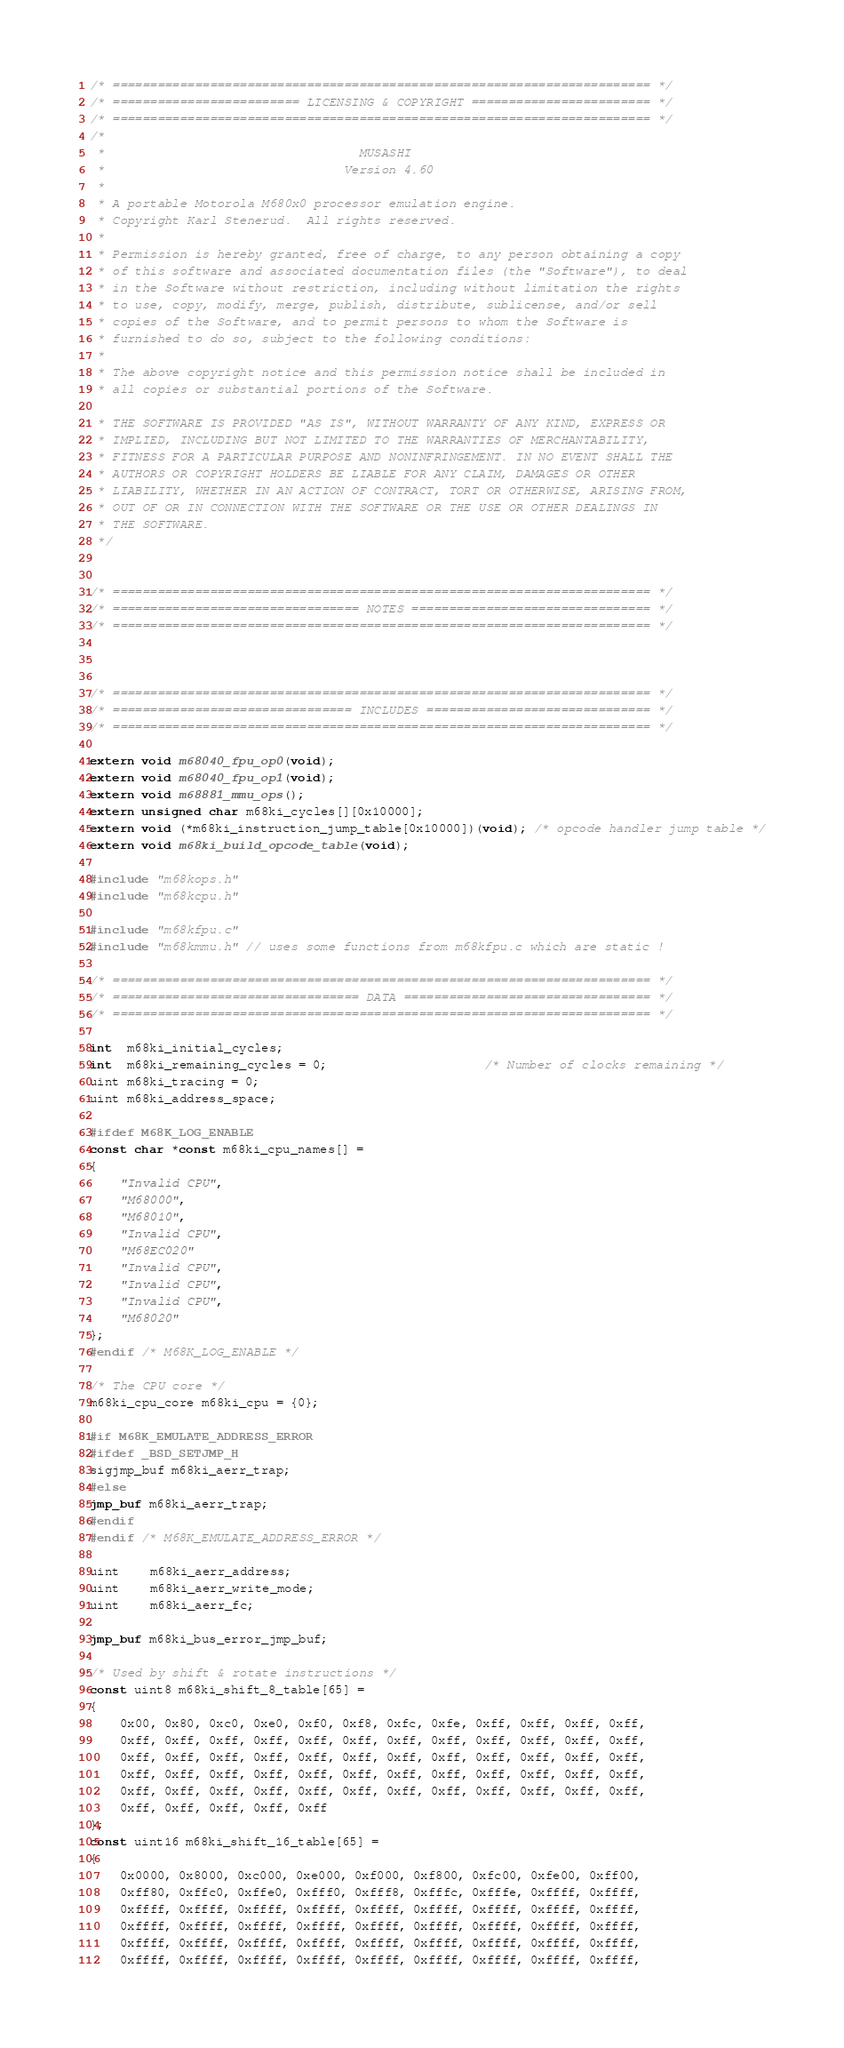Convert code to text. <code><loc_0><loc_0><loc_500><loc_500><_C_>/* ======================================================================== */
/* ========================= LICENSING & COPYRIGHT ======================== */
/* ======================================================================== */
/*
 *                                  MUSASHI
 *                                Version 4.60
 *
 * A portable Motorola M680x0 processor emulation engine.
 * Copyright Karl Stenerud.  All rights reserved.
 *
 * Permission is hereby granted, free of charge, to any person obtaining a copy
 * of this software and associated documentation files (the "Software"), to deal
 * in the Software without restriction, including without limitation the rights
 * to use, copy, modify, merge, publish, distribute, sublicense, and/or sell
 * copies of the Software, and to permit persons to whom the Software is
 * furnished to do so, subject to the following conditions:
 *
 * The above copyright notice and this permission notice shall be included in
 * all copies or substantial portions of the Software.

 * THE SOFTWARE IS PROVIDED "AS IS", WITHOUT WARRANTY OF ANY KIND, EXPRESS OR
 * IMPLIED, INCLUDING BUT NOT LIMITED TO THE WARRANTIES OF MERCHANTABILITY,
 * FITNESS FOR A PARTICULAR PURPOSE AND NONINFRINGEMENT. IN NO EVENT SHALL THE
 * AUTHORS OR COPYRIGHT HOLDERS BE LIABLE FOR ANY CLAIM, DAMAGES OR OTHER
 * LIABILITY, WHETHER IN AN ACTION OF CONTRACT, TORT OR OTHERWISE, ARISING FROM,
 * OUT OF OR IN CONNECTION WITH THE SOFTWARE OR THE USE OR OTHER DEALINGS IN
 * THE SOFTWARE.
 */


/* ======================================================================== */
/* ================================= NOTES ================================ */
/* ======================================================================== */



/* ======================================================================== */
/* ================================ INCLUDES ============================== */
/* ======================================================================== */

extern void m68040_fpu_op0(void);
extern void m68040_fpu_op1(void);
extern void m68881_mmu_ops();
extern unsigned char m68ki_cycles[][0x10000];
extern void (*m68ki_instruction_jump_table[0x10000])(void); /* opcode handler jump table */
extern void m68ki_build_opcode_table(void);

#include "m68kops.h"
#include "m68kcpu.h"

#include "m68kfpu.c"
#include "m68kmmu.h" // uses some functions from m68kfpu.c which are static !

/* ======================================================================== */
/* ================================= DATA ================================= */
/* ======================================================================== */

int  m68ki_initial_cycles;
int  m68ki_remaining_cycles = 0;                     /* Number of clocks remaining */
uint m68ki_tracing = 0;
uint m68ki_address_space;

#ifdef M68K_LOG_ENABLE
const char *const m68ki_cpu_names[] =
{
	"Invalid CPU",
	"M68000",
	"M68010",
	"Invalid CPU",
	"M68EC020"
	"Invalid CPU",
	"Invalid CPU",
	"Invalid CPU",
	"M68020"
};
#endif /* M68K_LOG_ENABLE */

/* The CPU core */
m68ki_cpu_core m68ki_cpu = {0};

#if M68K_EMULATE_ADDRESS_ERROR
#ifdef _BSD_SETJMP_H
sigjmp_buf m68ki_aerr_trap;
#else
jmp_buf m68ki_aerr_trap;
#endif
#endif /* M68K_EMULATE_ADDRESS_ERROR */

uint    m68ki_aerr_address;
uint    m68ki_aerr_write_mode;
uint    m68ki_aerr_fc;

jmp_buf m68ki_bus_error_jmp_buf;

/* Used by shift & rotate instructions */
const uint8 m68ki_shift_8_table[65] =
{
	0x00, 0x80, 0xc0, 0xe0, 0xf0, 0xf8, 0xfc, 0xfe, 0xff, 0xff, 0xff, 0xff,
	0xff, 0xff, 0xff, 0xff, 0xff, 0xff, 0xff, 0xff, 0xff, 0xff, 0xff, 0xff,
	0xff, 0xff, 0xff, 0xff, 0xff, 0xff, 0xff, 0xff, 0xff, 0xff, 0xff, 0xff,
	0xff, 0xff, 0xff, 0xff, 0xff, 0xff, 0xff, 0xff, 0xff, 0xff, 0xff, 0xff,
	0xff, 0xff, 0xff, 0xff, 0xff, 0xff, 0xff, 0xff, 0xff, 0xff, 0xff, 0xff,
	0xff, 0xff, 0xff, 0xff, 0xff
};
const uint16 m68ki_shift_16_table[65] =
{
	0x0000, 0x8000, 0xc000, 0xe000, 0xf000, 0xf800, 0xfc00, 0xfe00, 0xff00,
	0xff80, 0xffc0, 0xffe0, 0xfff0, 0xfff8, 0xfffc, 0xfffe, 0xffff, 0xffff,
	0xffff, 0xffff, 0xffff, 0xffff, 0xffff, 0xffff, 0xffff, 0xffff, 0xffff,
	0xffff, 0xffff, 0xffff, 0xffff, 0xffff, 0xffff, 0xffff, 0xffff, 0xffff,
	0xffff, 0xffff, 0xffff, 0xffff, 0xffff, 0xffff, 0xffff, 0xffff, 0xffff,
	0xffff, 0xffff, 0xffff, 0xffff, 0xffff, 0xffff, 0xffff, 0xffff, 0xffff,</code> 